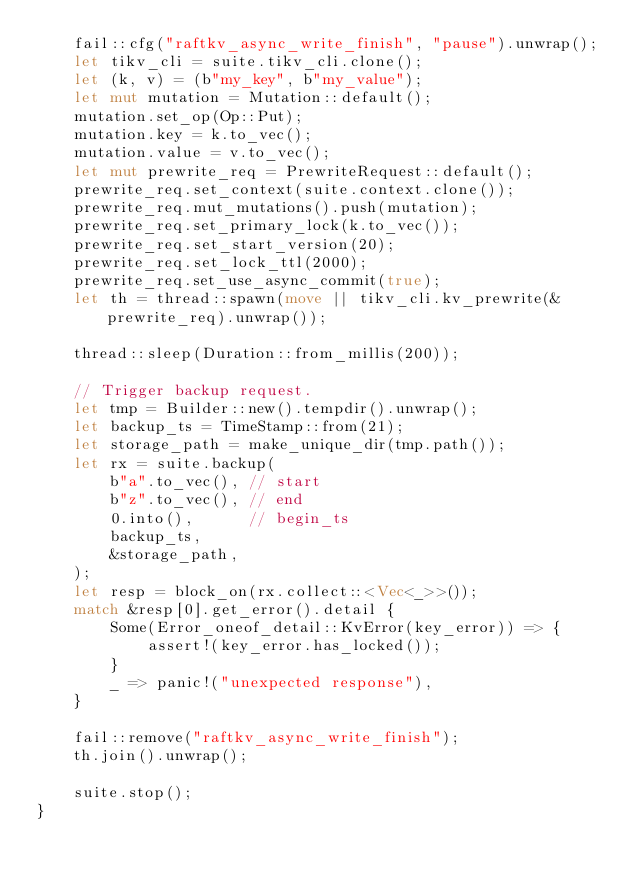Convert code to text. <code><loc_0><loc_0><loc_500><loc_500><_Rust_>    fail::cfg("raftkv_async_write_finish", "pause").unwrap();
    let tikv_cli = suite.tikv_cli.clone();
    let (k, v) = (b"my_key", b"my_value");
    let mut mutation = Mutation::default();
    mutation.set_op(Op::Put);
    mutation.key = k.to_vec();
    mutation.value = v.to_vec();
    let mut prewrite_req = PrewriteRequest::default();
    prewrite_req.set_context(suite.context.clone());
    prewrite_req.mut_mutations().push(mutation);
    prewrite_req.set_primary_lock(k.to_vec());
    prewrite_req.set_start_version(20);
    prewrite_req.set_lock_ttl(2000);
    prewrite_req.set_use_async_commit(true);
    let th = thread::spawn(move || tikv_cli.kv_prewrite(&prewrite_req).unwrap());

    thread::sleep(Duration::from_millis(200));

    // Trigger backup request.
    let tmp = Builder::new().tempdir().unwrap();
    let backup_ts = TimeStamp::from(21);
    let storage_path = make_unique_dir(tmp.path());
    let rx = suite.backup(
        b"a".to_vec(), // start
        b"z".to_vec(), // end
        0.into(),      // begin_ts
        backup_ts,
        &storage_path,
    );
    let resp = block_on(rx.collect::<Vec<_>>());
    match &resp[0].get_error().detail {
        Some(Error_oneof_detail::KvError(key_error)) => {
            assert!(key_error.has_locked());
        }
        _ => panic!("unexpected response"),
    }

    fail::remove("raftkv_async_write_finish");
    th.join().unwrap();

    suite.stop();
}
</code> 